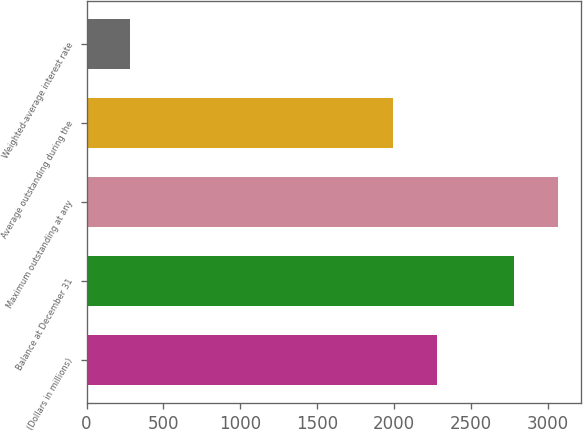Convert chart to OTSL. <chart><loc_0><loc_0><loc_500><loc_500><bar_chart><fcel>(Dollars in millions)<fcel>Balance at December 31<fcel>Maximum outstanding at any<fcel>Average outstanding during the<fcel>Weighted-average interest rate<nl><fcel>2278.08<fcel>2777<fcel>3062.08<fcel>1993<fcel>285.29<nl></chart> 